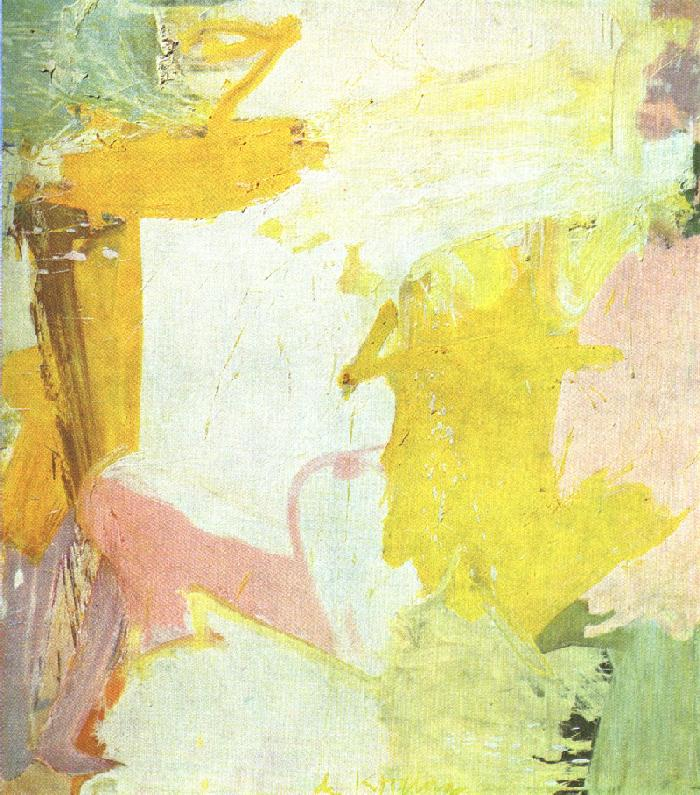Describe how the artist has used color and texture in this painting. The artist has masterfully employed a pastel color palette, predominantly featuring hues of yellow, pink, and white. The blending of these colors creates a gentle and soothing effect. The texture is achieved through a variety of brushstrokes, ranging from broad, sweeping strokes to more intricate details. This combination of colors and textures gives the piece a rich, layered appearance, adding depth and dimension to the abstract forms. The use of color and texture also contributes to the overall mood of the painting, which is light, airy, and full of subtle movement. Can you explain how the abstract forms contribute to the overall feeling of the painting? The abstract forms in this painting play a pivotal role in creating a sense of harmony and balance. The soft edges and fluid shapes suggest a sense of movement and continuity, guiding the viewer's eye across the canvas. These forms do not depict any specific objects, allowing the viewer to interpret them in a personal and subjective manner. This invites a deeper emotional connection with the artwork, as each viewer may see something different in the abstract shapes. The overall feeling of the painting is one of tranquility and lightness, largely due to the flowing, organic forms that dominate the composition. 